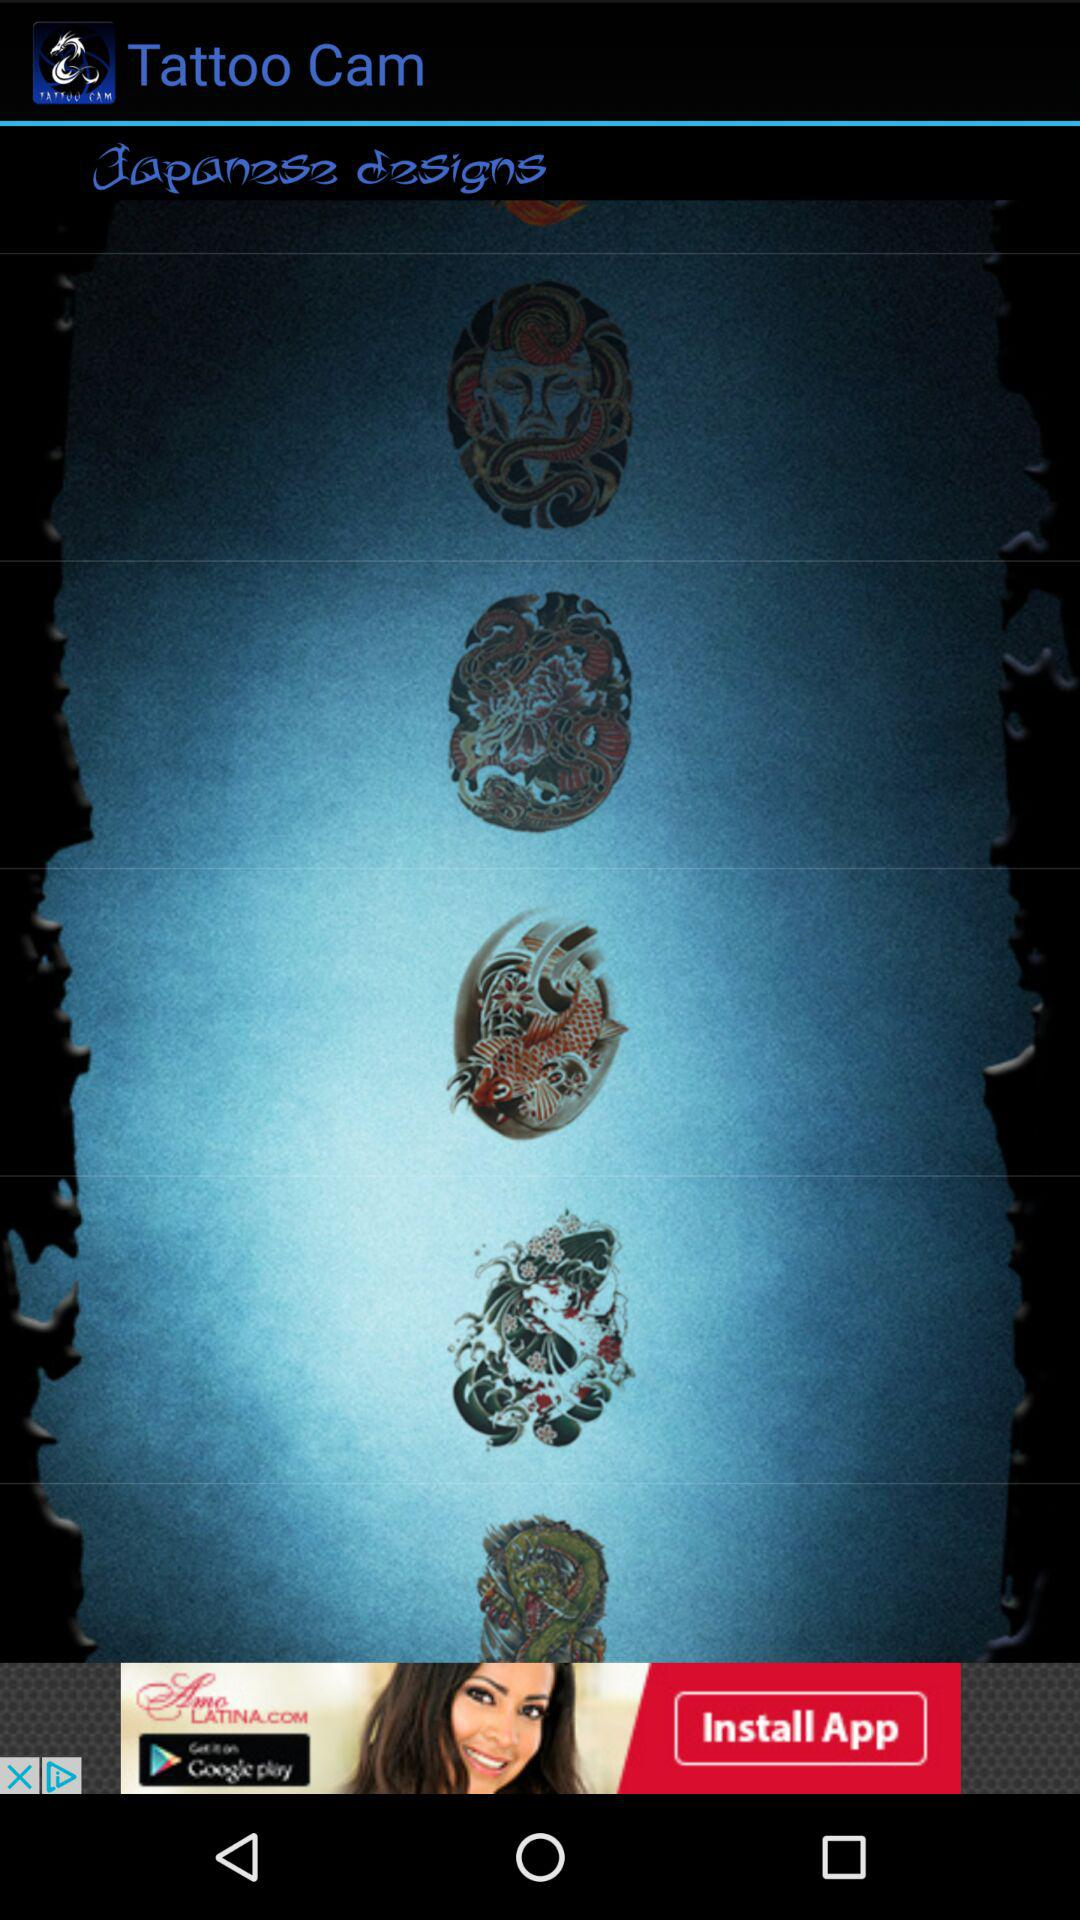Which types of tattoo designs are given? The given type is Japanese design. 